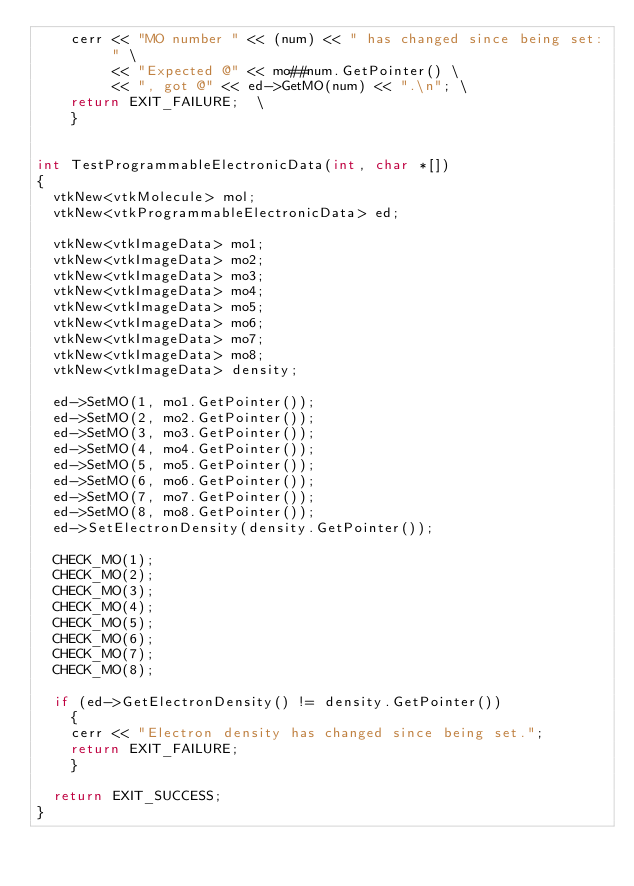Convert code to text. <code><loc_0><loc_0><loc_500><loc_500><_C++_>    cerr << "MO number " << (num) << " has changed since being set: " \
         << "Expected @" << mo##num.GetPointer() \
         << ", got @" << ed->GetMO(num) << ".\n"; \
    return EXIT_FAILURE;  \
    }


int TestProgrammableElectronicData(int, char *[])
{
  vtkNew<vtkMolecule> mol;
  vtkNew<vtkProgrammableElectronicData> ed;

  vtkNew<vtkImageData> mo1;
  vtkNew<vtkImageData> mo2;
  vtkNew<vtkImageData> mo3;
  vtkNew<vtkImageData> mo4;
  vtkNew<vtkImageData> mo5;
  vtkNew<vtkImageData> mo6;
  vtkNew<vtkImageData> mo7;
  vtkNew<vtkImageData> mo8;
  vtkNew<vtkImageData> density;

  ed->SetMO(1, mo1.GetPointer());
  ed->SetMO(2, mo2.GetPointer());
  ed->SetMO(3, mo3.GetPointer());
  ed->SetMO(4, mo4.GetPointer());
  ed->SetMO(5, mo5.GetPointer());
  ed->SetMO(6, mo6.GetPointer());
  ed->SetMO(7, mo7.GetPointer());
  ed->SetMO(8, mo8.GetPointer());
  ed->SetElectronDensity(density.GetPointer());

  CHECK_MO(1);
  CHECK_MO(2);
  CHECK_MO(3);
  CHECK_MO(4);
  CHECK_MO(5);
  CHECK_MO(6);
  CHECK_MO(7);
  CHECK_MO(8);

  if (ed->GetElectronDensity() != density.GetPointer())
    {
    cerr << "Electron density has changed since being set.";
    return EXIT_FAILURE;
    }

  return EXIT_SUCCESS;
}
</code> 